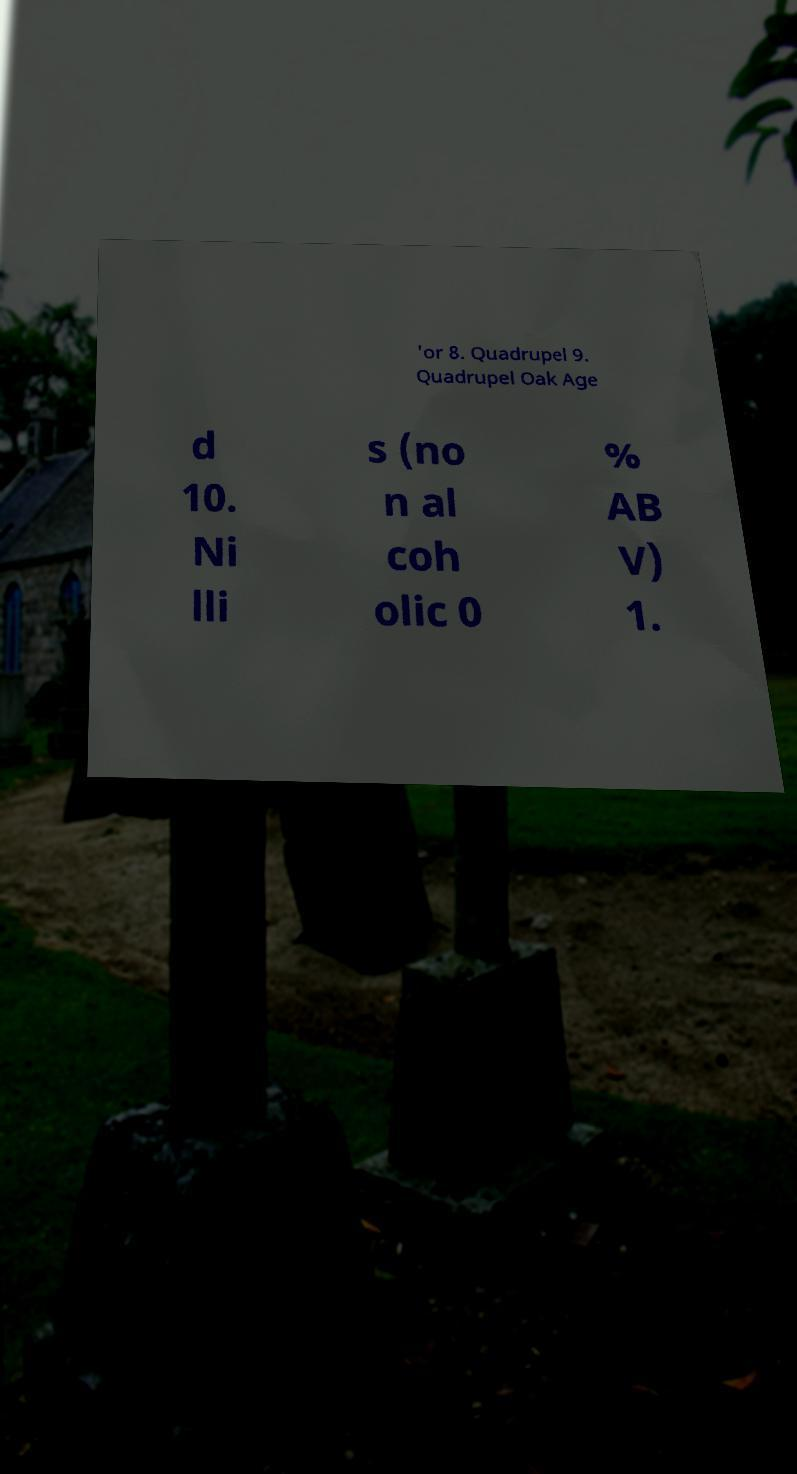What messages or text are displayed in this image? I need them in a readable, typed format. 'or 8. Quadrupel 9. Quadrupel Oak Age d 10. Ni lli s (no n al coh olic 0 % AB V) 1. 